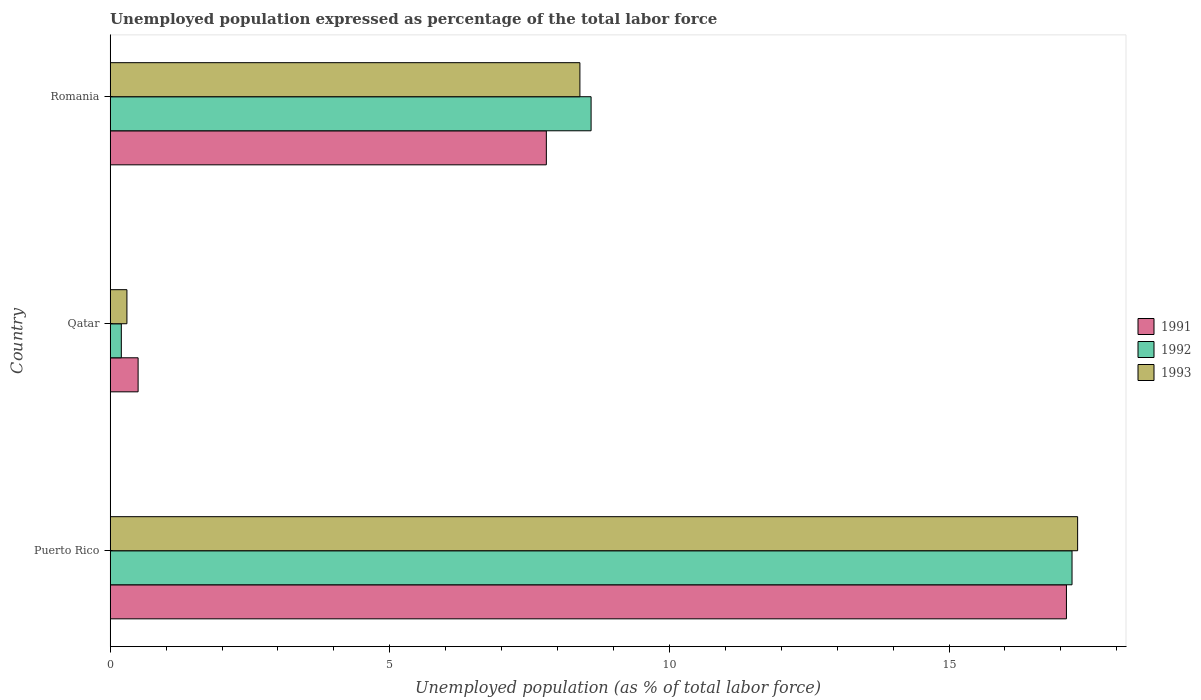How many bars are there on the 1st tick from the top?
Offer a terse response. 3. What is the label of the 2nd group of bars from the top?
Offer a very short reply. Qatar. In how many cases, is the number of bars for a given country not equal to the number of legend labels?
Ensure brevity in your answer.  0. What is the unemployment in in 1991 in Puerto Rico?
Offer a very short reply. 17.1. Across all countries, what is the maximum unemployment in in 1991?
Your answer should be very brief. 17.1. Across all countries, what is the minimum unemployment in in 1993?
Ensure brevity in your answer.  0.3. In which country was the unemployment in in 1993 maximum?
Your response must be concise. Puerto Rico. In which country was the unemployment in in 1991 minimum?
Your answer should be very brief. Qatar. What is the total unemployment in in 1993 in the graph?
Provide a succinct answer. 26. What is the difference between the unemployment in in 1993 in Puerto Rico and that in Romania?
Your answer should be compact. 8.9. What is the difference between the unemployment in in 1991 in Qatar and the unemployment in in 1992 in Puerto Rico?
Offer a very short reply. -16.7. What is the average unemployment in in 1992 per country?
Give a very brief answer. 8.67. What is the difference between the unemployment in in 1991 and unemployment in in 1993 in Romania?
Offer a very short reply. -0.6. In how many countries, is the unemployment in in 1992 greater than 9 %?
Make the answer very short. 1. What is the ratio of the unemployment in in 1993 in Puerto Rico to that in Qatar?
Make the answer very short. 57.67. Is the unemployment in in 1993 in Puerto Rico less than that in Romania?
Provide a succinct answer. No. Is the difference between the unemployment in in 1991 in Puerto Rico and Qatar greater than the difference between the unemployment in in 1993 in Puerto Rico and Qatar?
Provide a short and direct response. No. What is the difference between the highest and the second highest unemployment in in 1992?
Make the answer very short. 8.6. What is the difference between the highest and the lowest unemployment in in 1991?
Offer a terse response. 16.6. In how many countries, is the unemployment in in 1993 greater than the average unemployment in in 1993 taken over all countries?
Ensure brevity in your answer.  1. Is the sum of the unemployment in in 1993 in Puerto Rico and Romania greater than the maximum unemployment in in 1991 across all countries?
Offer a terse response. Yes. What does the 3rd bar from the bottom in Romania represents?
Offer a very short reply. 1993. How many countries are there in the graph?
Provide a short and direct response. 3. Are the values on the major ticks of X-axis written in scientific E-notation?
Your answer should be compact. No. Does the graph contain grids?
Keep it short and to the point. No. How many legend labels are there?
Provide a succinct answer. 3. What is the title of the graph?
Provide a short and direct response. Unemployed population expressed as percentage of the total labor force. Does "1973" appear as one of the legend labels in the graph?
Ensure brevity in your answer.  No. What is the label or title of the X-axis?
Offer a terse response. Unemployed population (as % of total labor force). What is the Unemployed population (as % of total labor force) in 1991 in Puerto Rico?
Offer a very short reply. 17.1. What is the Unemployed population (as % of total labor force) in 1992 in Puerto Rico?
Make the answer very short. 17.2. What is the Unemployed population (as % of total labor force) of 1993 in Puerto Rico?
Keep it short and to the point. 17.3. What is the Unemployed population (as % of total labor force) in 1991 in Qatar?
Your response must be concise. 0.5. What is the Unemployed population (as % of total labor force) in 1992 in Qatar?
Offer a terse response. 0.2. What is the Unemployed population (as % of total labor force) in 1993 in Qatar?
Provide a succinct answer. 0.3. What is the Unemployed population (as % of total labor force) in 1991 in Romania?
Provide a short and direct response. 7.8. What is the Unemployed population (as % of total labor force) of 1992 in Romania?
Make the answer very short. 8.6. What is the Unemployed population (as % of total labor force) in 1993 in Romania?
Keep it short and to the point. 8.4. Across all countries, what is the maximum Unemployed population (as % of total labor force) of 1991?
Make the answer very short. 17.1. Across all countries, what is the maximum Unemployed population (as % of total labor force) in 1992?
Provide a short and direct response. 17.2. Across all countries, what is the maximum Unemployed population (as % of total labor force) in 1993?
Your answer should be compact. 17.3. Across all countries, what is the minimum Unemployed population (as % of total labor force) in 1991?
Your response must be concise. 0.5. Across all countries, what is the minimum Unemployed population (as % of total labor force) in 1992?
Ensure brevity in your answer.  0.2. Across all countries, what is the minimum Unemployed population (as % of total labor force) of 1993?
Offer a very short reply. 0.3. What is the total Unemployed population (as % of total labor force) in 1991 in the graph?
Your response must be concise. 25.4. What is the total Unemployed population (as % of total labor force) of 1992 in the graph?
Ensure brevity in your answer.  26. What is the difference between the Unemployed population (as % of total labor force) of 1991 in Puerto Rico and that in Qatar?
Offer a terse response. 16.6. What is the difference between the Unemployed population (as % of total labor force) in 1992 in Puerto Rico and that in Qatar?
Offer a terse response. 17. What is the difference between the Unemployed population (as % of total labor force) of 1993 in Puerto Rico and that in Qatar?
Offer a very short reply. 17. What is the difference between the Unemployed population (as % of total labor force) in 1991 in Puerto Rico and that in Romania?
Give a very brief answer. 9.3. What is the difference between the Unemployed population (as % of total labor force) in 1993 in Puerto Rico and that in Romania?
Keep it short and to the point. 8.9. What is the difference between the Unemployed population (as % of total labor force) in 1992 in Qatar and that in Romania?
Offer a very short reply. -8.4. What is the difference between the Unemployed population (as % of total labor force) in 1991 in Puerto Rico and the Unemployed population (as % of total labor force) in 1992 in Qatar?
Your answer should be very brief. 16.9. What is the difference between the Unemployed population (as % of total labor force) in 1991 in Puerto Rico and the Unemployed population (as % of total labor force) in 1993 in Qatar?
Offer a terse response. 16.8. What is the difference between the Unemployed population (as % of total labor force) of 1992 in Puerto Rico and the Unemployed population (as % of total labor force) of 1993 in Qatar?
Offer a terse response. 16.9. What is the difference between the Unemployed population (as % of total labor force) in 1991 in Puerto Rico and the Unemployed population (as % of total labor force) in 1993 in Romania?
Provide a succinct answer. 8.7. What is the difference between the Unemployed population (as % of total labor force) of 1992 in Puerto Rico and the Unemployed population (as % of total labor force) of 1993 in Romania?
Offer a very short reply. 8.8. What is the difference between the Unemployed population (as % of total labor force) of 1991 in Qatar and the Unemployed population (as % of total labor force) of 1992 in Romania?
Your response must be concise. -8.1. What is the difference between the Unemployed population (as % of total labor force) of 1991 in Qatar and the Unemployed population (as % of total labor force) of 1993 in Romania?
Offer a very short reply. -7.9. What is the average Unemployed population (as % of total labor force) of 1991 per country?
Your answer should be compact. 8.47. What is the average Unemployed population (as % of total labor force) in 1992 per country?
Offer a very short reply. 8.67. What is the average Unemployed population (as % of total labor force) in 1993 per country?
Ensure brevity in your answer.  8.67. What is the difference between the Unemployed population (as % of total labor force) in 1991 and Unemployed population (as % of total labor force) in 1992 in Puerto Rico?
Your response must be concise. -0.1. What is the difference between the Unemployed population (as % of total labor force) of 1992 and Unemployed population (as % of total labor force) of 1993 in Puerto Rico?
Keep it short and to the point. -0.1. What is the difference between the Unemployed population (as % of total labor force) in 1991 and Unemployed population (as % of total labor force) in 1993 in Qatar?
Make the answer very short. 0.2. What is the difference between the Unemployed population (as % of total labor force) in 1992 and Unemployed population (as % of total labor force) in 1993 in Qatar?
Your response must be concise. -0.1. What is the ratio of the Unemployed population (as % of total labor force) of 1991 in Puerto Rico to that in Qatar?
Offer a very short reply. 34.2. What is the ratio of the Unemployed population (as % of total labor force) in 1992 in Puerto Rico to that in Qatar?
Offer a terse response. 86. What is the ratio of the Unemployed population (as % of total labor force) in 1993 in Puerto Rico to that in Qatar?
Keep it short and to the point. 57.67. What is the ratio of the Unemployed population (as % of total labor force) in 1991 in Puerto Rico to that in Romania?
Keep it short and to the point. 2.19. What is the ratio of the Unemployed population (as % of total labor force) of 1993 in Puerto Rico to that in Romania?
Give a very brief answer. 2.06. What is the ratio of the Unemployed population (as % of total labor force) of 1991 in Qatar to that in Romania?
Your answer should be compact. 0.06. What is the ratio of the Unemployed population (as % of total labor force) in 1992 in Qatar to that in Romania?
Ensure brevity in your answer.  0.02. What is the ratio of the Unemployed population (as % of total labor force) of 1993 in Qatar to that in Romania?
Give a very brief answer. 0.04. What is the difference between the highest and the second highest Unemployed population (as % of total labor force) in 1992?
Give a very brief answer. 8.6. What is the difference between the highest and the lowest Unemployed population (as % of total labor force) in 1992?
Your answer should be compact. 17. 